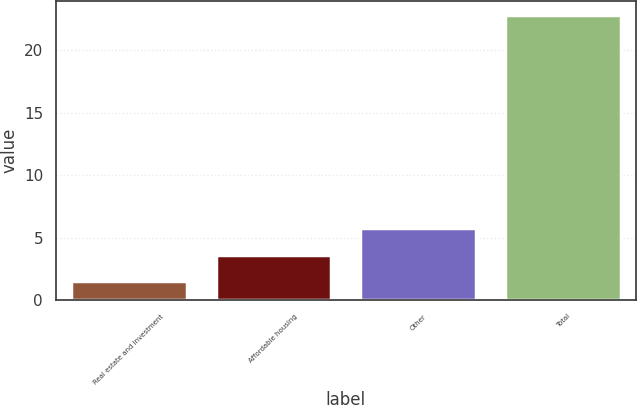<chart> <loc_0><loc_0><loc_500><loc_500><bar_chart><fcel>Real estate and investment<fcel>Affordable housing<fcel>Other<fcel>Total<nl><fcel>1.5<fcel>3.63<fcel>5.76<fcel>22.8<nl></chart> 